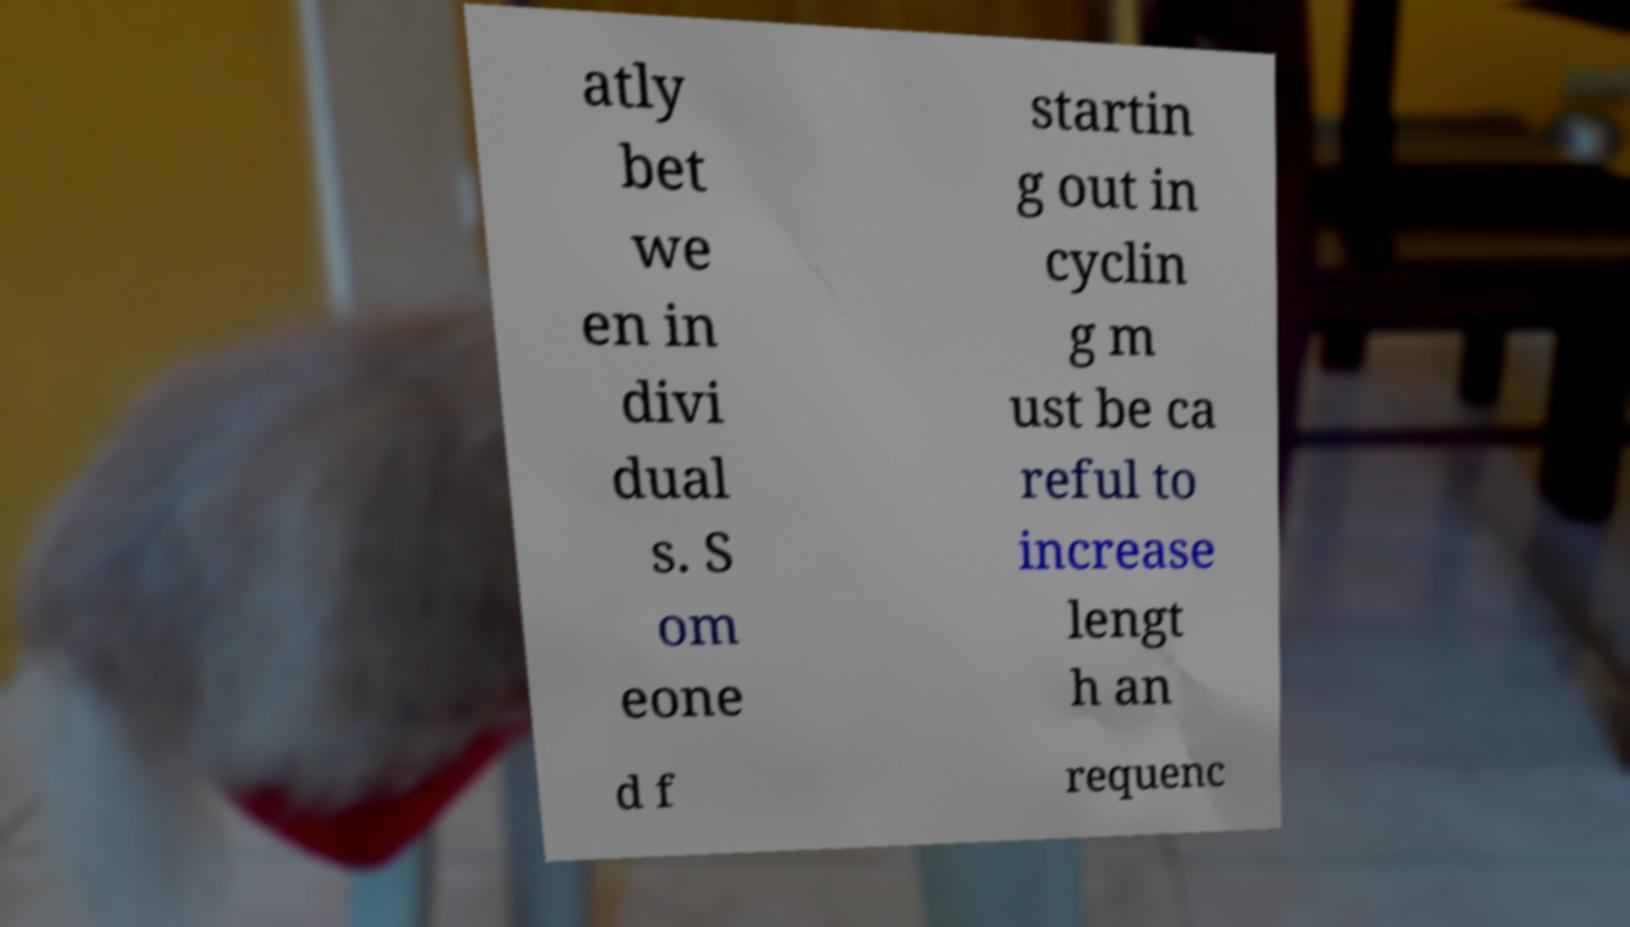Can you read and provide the text displayed in the image?This photo seems to have some interesting text. Can you extract and type it out for me? atly bet we en in divi dual s. S om eone startin g out in cyclin g m ust be ca reful to increase lengt h an d f requenc 